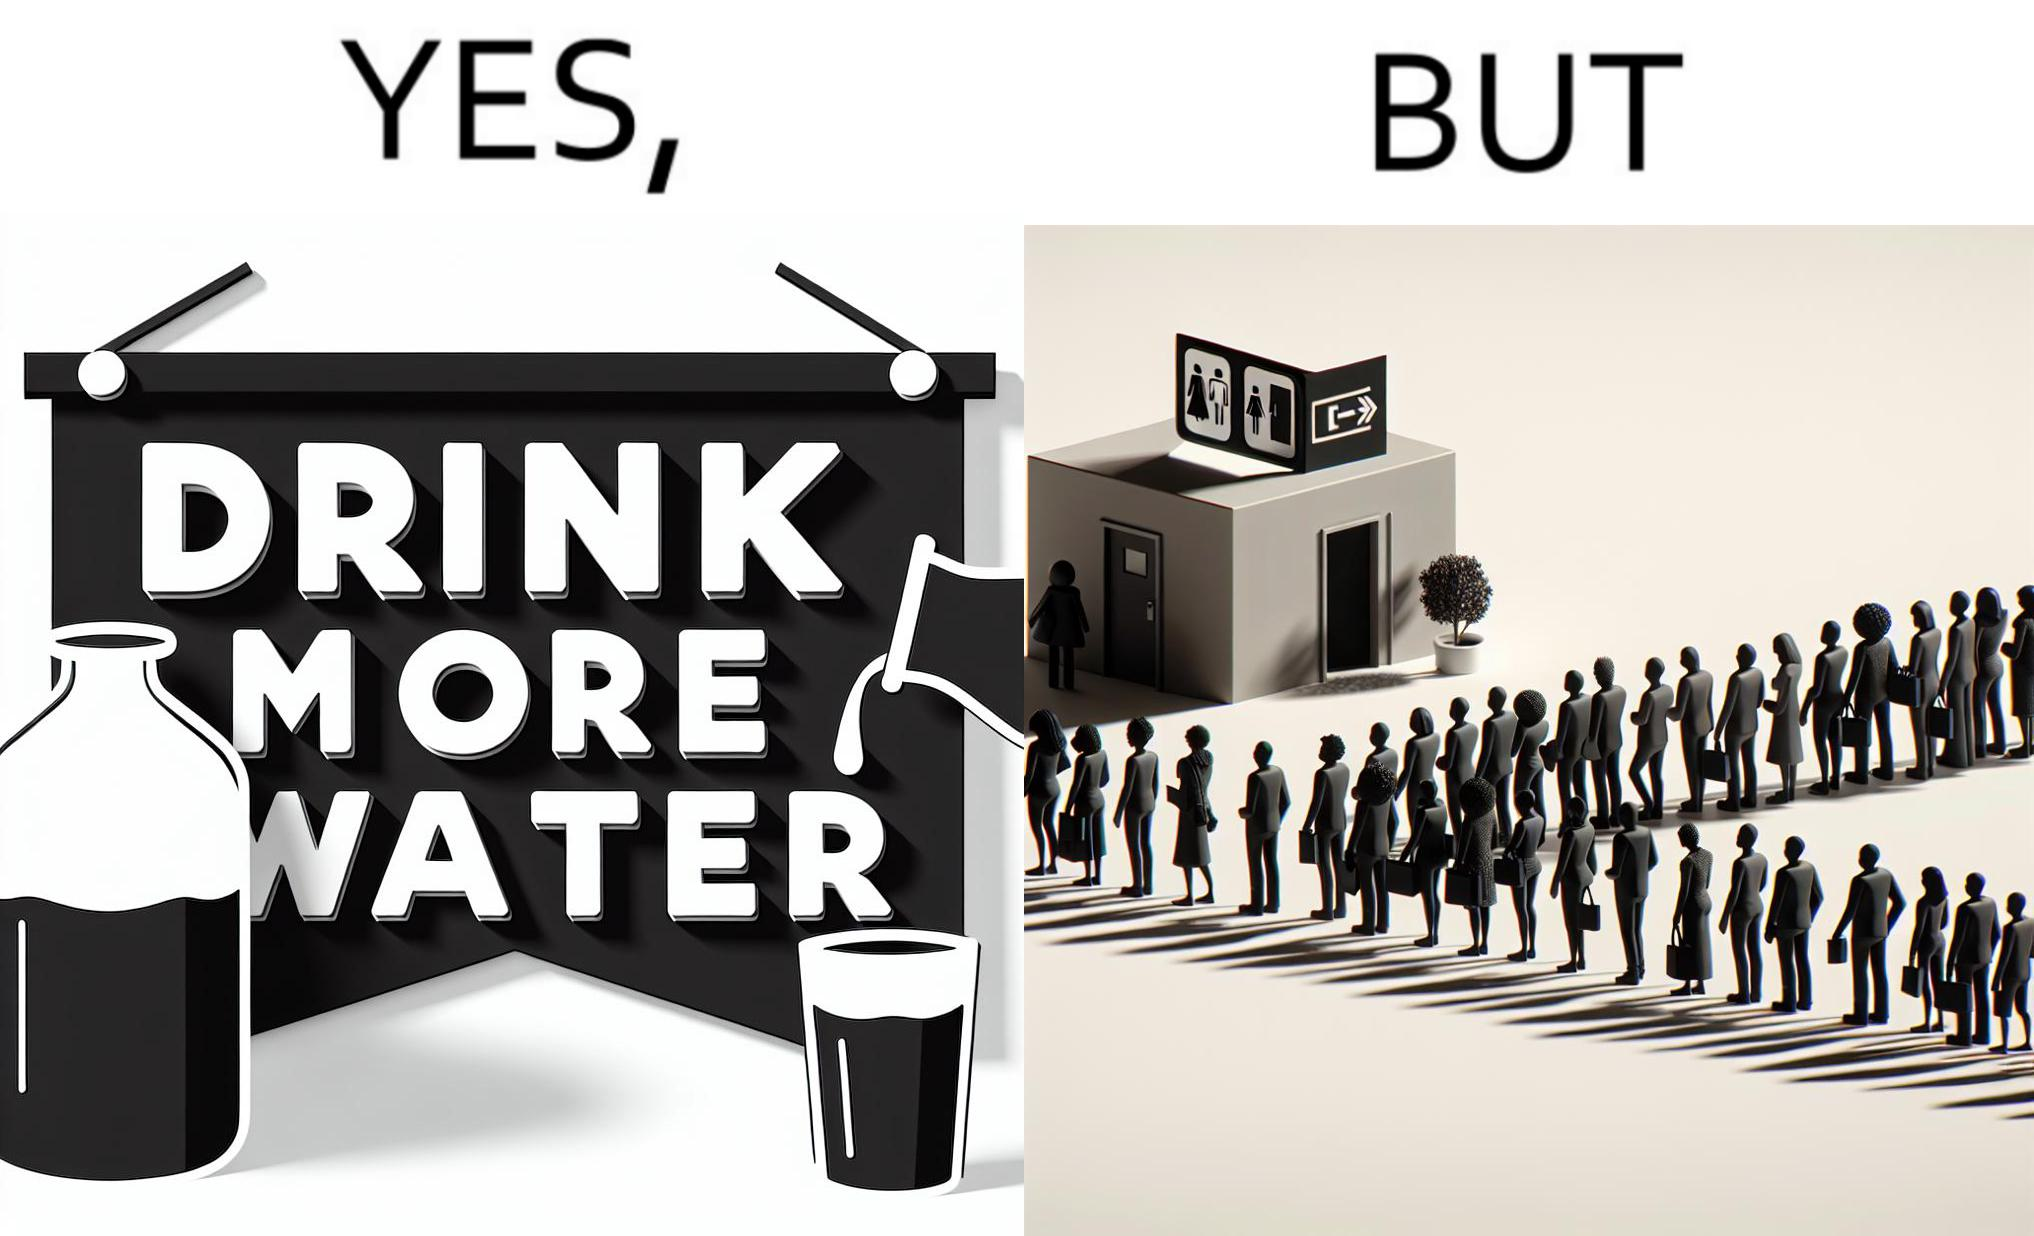Would you classify this image as satirical? Yes, this image is satirical. 